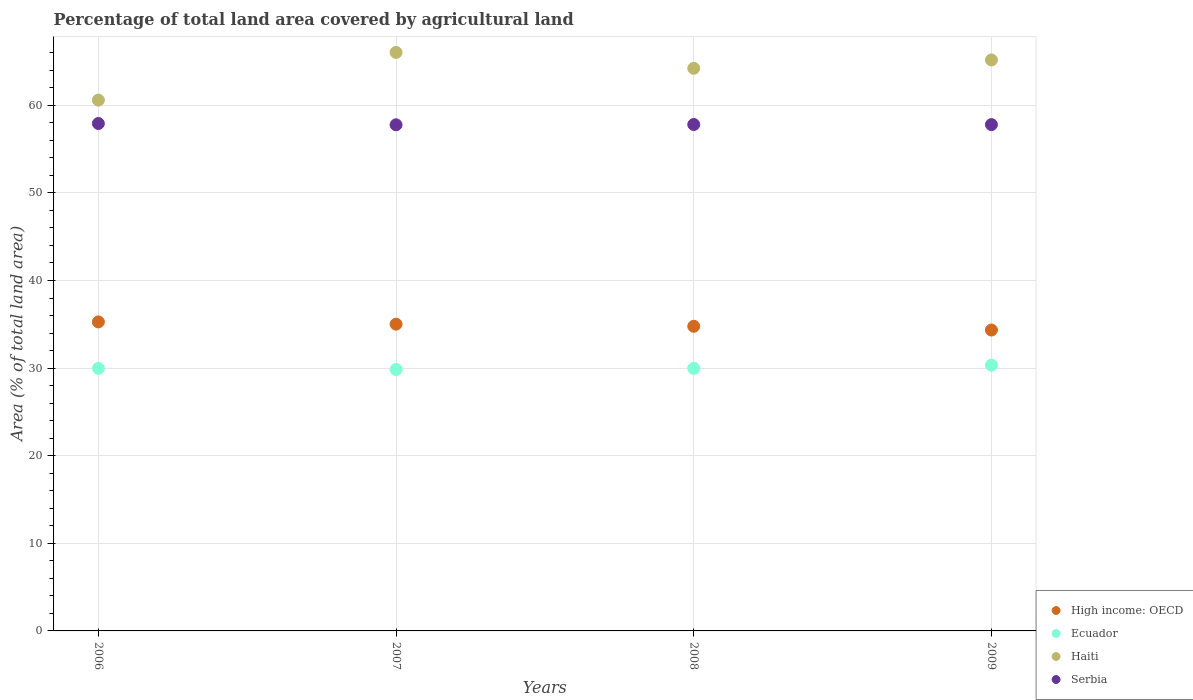How many different coloured dotlines are there?
Keep it short and to the point. 4. Is the number of dotlines equal to the number of legend labels?
Offer a very short reply. Yes. What is the percentage of agricultural land in Serbia in 2009?
Your answer should be compact. 57.8. Across all years, what is the maximum percentage of agricultural land in High income: OECD?
Give a very brief answer. 35.28. Across all years, what is the minimum percentage of agricultural land in Haiti?
Keep it short and to the point. 60.6. In which year was the percentage of agricultural land in Ecuador minimum?
Give a very brief answer. 2007. What is the total percentage of agricultural land in Ecuador in the graph?
Offer a very short reply. 120.13. What is the difference between the percentage of agricultural land in Ecuador in 2006 and that in 2008?
Offer a terse response. -0. What is the difference between the percentage of agricultural land in Serbia in 2007 and the percentage of agricultural land in Ecuador in 2008?
Offer a very short reply. 27.8. What is the average percentage of agricultural land in Ecuador per year?
Ensure brevity in your answer.  30.03. In the year 2006, what is the difference between the percentage of agricultural land in Serbia and percentage of agricultural land in Ecuador?
Give a very brief answer. 27.95. In how many years, is the percentage of agricultural land in High income: OECD greater than 16 %?
Make the answer very short. 4. What is the ratio of the percentage of agricultural land in Ecuador in 2007 to that in 2008?
Offer a terse response. 1. What is the difference between the highest and the second highest percentage of agricultural land in Ecuador?
Give a very brief answer. 0.36. What is the difference between the highest and the lowest percentage of agricultural land in Serbia?
Your answer should be compact. 0.15. In how many years, is the percentage of agricultural land in Ecuador greater than the average percentage of agricultural land in Ecuador taken over all years?
Give a very brief answer. 1. Is the sum of the percentage of agricultural land in Ecuador in 2006 and 2007 greater than the maximum percentage of agricultural land in High income: OECD across all years?
Provide a succinct answer. Yes. Is it the case that in every year, the sum of the percentage of agricultural land in High income: OECD and percentage of agricultural land in Serbia  is greater than the sum of percentage of agricultural land in Ecuador and percentage of agricultural land in Haiti?
Offer a terse response. Yes. Is the percentage of agricultural land in Ecuador strictly less than the percentage of agricultural land in Haiti over the years?
Make the answer very short. Yes. How many dotlines are there?
Offer a terse response. 4. Does the graph contain grids?
Provide a short and direct response. Yes. How are the legend labels stacked?
Offer a terse response. Vertical. What is the title of the graph?
Provide a succinct answer. Percentage of total land area covered by agricultural land. Does "Palau" appear as one of the legend labels in the graph?
Offer a very short reply. No. What is the label or title of the Y-axis?
Make the answer very short. Area (% of total land area). What is the Area (% of total land area) in High income: OECD in 2006?
Offer a terse response. 35.28. What is the Area (% of total land area) in Ecuador in 2006?
Provide a short and direct response. 29.97. What is the Area (% of total land area) of Haiti in 2006?
Offer a very short reply. 60.6. What is the Area (% of total land area) in Serbia in 2006?
Offer a very short reply. 57.92. What is the Area (% of total land area) of High income: OECD in 2007?
Your answer should be compact. 35.02. What is the Area (% of total land area) of Ecuador in 2007?
Offer a very short reply. 29.84. What is the Area (% of total land area) of Haiti in 2007?
Keep it short and to the point. 66.04. What is the Area (% of total land area) in Serbia in 2007?
Keep it short and to the point. 57.77. What is the Area (% of total land area) of High income: OECD in 2008?
Your response must be concise. 34.77. What is the Area (% of total land area) in Ecuador in 2008?
Provide a short and direct response. 29.98. What is the Area (% of total land area) in Haiti in 2008?
Give a very brief answer. 64.22. What is the Area (% of total land area) in Serbia in 2008?
Your answer should be compact. 57.81. What is the Area (% of total land area) in High income: OECD in 2009?
Provide a short and direct response. 34.35. What is the Area (% of total land area) of Ecuador in 2009?
Provide a succinct answer. 30.34. What is the Area (% of total land area) of Haiti in 2009?
Keep it short and to the point. 65.18. What is the Area (% of total land area) of Serbia in 2009?
Ensure brevity in your answer.  57.8. Across all years, what is the maximum Area (% of total land area) in High income: OECD?
Keep it short and to the point. 35.28. Across all years, what is the maximum Area (% of total land area) in Ecuador?
Your answer should be compact. 30.34. Across all years, what is the maximum Area (% of total land area) in Haiti?
Provide a succinct answer. 66.04. Across all years, what is the maximum Area (% of total land area) in Serbia?
Your response must be concise. 57.92. Across all years, what is the minimum Area (% of total land area) in High income: OECD?
Give a very brief answer. 34.35. Across all years, what is the minimum Area (% of total land area) of Ecuador?
Provide a succinct answer. 29.84. Across all years, what is the minimum Area (% of total land area) of Haiti?
Offer a very short reply. 60.6. Across all years, what is the minimum Area (% of total land area) of Serbia?
Provide a short and direct response. 57.77. What is the total Area (% of total land area) in High income: OECD in the graph?
Keep it short and to the point. 139.42. What is the total Area (% of total land area) of Ecuador in the graph?
Your response must be concise. 120.13. What is the total Area (% of total land area) in Haiti in the graph?
Your response must be concise. 256.04. What is the total Area (% of total land area) in Serbia in the graph?
Ensure brevity in your answer.  231.31. What is the difference between the Area (% of total land area) in High income: OECD in 2006 and that in 2007?
Your answer should be compact. 0.26. What is the difference between the Area (% of total land area) of Ecuador in 2006 and that in 2007?
Give a very brief answer. 0.13. What is the difference between the Area (% of total land area) of Haiti in 2006 and that in 2007?
Your answer should be compact. -5.44. What is the difference between the Area (% of total land area) of Serbia in 2006 and that in 2007?
Your response must be concise. 0.15. What is the difference between the Area (% of total land area) of High income: OECD in 2006 and that in 2008?
Ensure brevity in your answer.  0.5. What is the difference between the Area (% of total land area) in Ecuador in 2006 and that in 2008?
Give a very brief answer. -0. What is the difference between the Area (% of total land area) in Haiti in 2006 and that in 2008?
Provide a short and direct response. -3.63. What is the difference between the Area (% of total land area) of Serbia in 2006 and that in 2008?
Keep it short and to the point. 0.11. What is the difference between the Area (% of total land area) of High income: OECD in 2006 and that in 2009?
Provide a succinct answer. 0.93. What is the difference between the Area (% of total land area) of Ecuador in 2006 and that in 2009?
Offer a very short reply. -0.36. What is the difference between the Area (% of total land area) of Haiti in 2006 and that in 2009?
Your response must be concise. -4.58. What is the difference between the Area (% of total land area) of Serbia in 2006 and that in 2009?
Provide a succinct answer. 0.13. What is the difference between the Area (% of total land area) of High income: OECD in 2007 and that in 2008?
Offer a very short reply. 0.24. What is the difference between the Area (% of total land area) in Ecuador in 2007 and that in 2008?
Provide a succinct answer. -0.13. What is the difference between the Area (% of total land area) in Haiti in 2007 and that in 2008?
Keep it short and to the point. 1.81. What is the difference between the Area (% of total land area) of Serbia in 2007 and that in 2008?
Provide a short and direct response. -0.03. What is the difference between the Area (% of total land area) in High income: OECD in 2007 and that in 2009?
Give a very brief answer. 0.67. What is the difference between the Area (% of total land area) of Ecuador in 2007 and that in 2009?
Provide a succinct answer. -0.49. What is the difference between the Area (% of total land area) in Haiti in 2007 and that in 2009?
Your answer should be compact. 0.86. What is the difference between the Area (% of total land area) in Serbia in 2007 and that in 2009?
Make the answer very short. -0.02. What is the difference between the Area (% of total land area) of High income: OECD in 2008 and that in 2009?
Your answer should be compact. 0.43. What is the difference between the Area (% of total land area) in Ecuador in 2008 and that in 2009?
Your answer should be compact. -0.36. What is the difference between the Area (% of total land area) in Haiti in 2008 and that in 2009?
Provide a short and direct response. -0.96. What is the difference between the Area (% of total land area) of Serbia in 2008 and that in 2009?
Make the answer very short. 0.01. What is the difference between the Area (% of total land area) of High income: OECD in 2006 and the Area (% of total land area) of Ecuador in 2007?
Your response must be concise. 5.43. What is the difference between the Area (% of total land area) in High income: OECD in 2006 and the Area (% of total land area) in Haiti in 2007?
Keep it short and to the point. -30.76. What is the difference between the Area (% of total land area) in High income: OECD in 2006 and the Area (% of total land area) in Serbia in 2007?
Offer a terse response. -22.5. What is the difference between the Area (% of total land area) of Ecuador in 2006 and the Area (% of total land area) of Haiti in 2007?
Your answer should be compact. -36.07. What is the difference between the Area (% of total land area) in Ecuador in 2006 and the Area (% of total land area) in Serbia in 2007?
Offer a terse response. -27.8. What is the difference between the Area (% of total land area) in Haiti in 2006 and the Area (% of total land area) in Serbia in 2007?
Offer a terse response. 2.82. What is the difference between the Area (% of total land area) of High income: OECD in 2006 and the Area (% of total land area) of Ecuador in 2008?
Offer a terse response. 5.3. What is the difference between the Area (% of total land area) in High income: OECD in 2006 and the Area (% of total land area) in Haiti in 2008?
Offer a terse response. -28.95. What is the difference between the Area (% of total land area) in High income: OECD in 2006 and the Area (% of total land area) in Serbia in 2008?
Your answer should be very brief. -22.53. What is the difference between the Area (% of total land area) in Ecuador in 2006 and the Area (% of total land area) in Haiti in 2008?
Offer a terse response. -34.25. What is the difference between the Area (% of total land area) of Ecuador in 2006 and the Area (% of total land area) of Serbia in 2008?
Give a very brief answer. -27.84. What is the difference between the Area (% of total land area) of Haiti in 2006 and the Area (% of total land area) of Serbia in 2008?
Provide a short and direct response. 2.79. What is the difference between the Area (% of total land area) of High income: OECD in 2006 and the Area (% of total land area) of Ecuador in 2009?
Provide a succinct answer. 4.94. What is the difference between the Area (% of total land area) of High income: OECD in 2006 and the Area (% of total land area) of Haiti in 2009?
Keep it short and to the point. -29.9. What is the difference between the Area (% of total land area) in High income: OECD in 2006 and the Area (% of total land area) in Serbia in 2009?
Offer a terse response. -22.52. What is the difference between the Area (% of total land area) of Ecuador in 2006 and the Area (% of total land area) of Haiti in 2009?
Offer a very short reply. -35.21. What is the difference between the Area (% of total land area) of Ecuador in 2006 and the Area (% of total land area) of Serbia in 2009?
Give a very brief answer. -27.83. What is the difference between the Area (% of total land area) of Haiti in 2006 and the Area (% of total land area) of Serbia in 2009?
Your answer should be very brief. 2.8. What is the difference between the Area (% of total land area) of High income: OECD in 2007 and the Area (% of total land area) of Ecuador in 2008?
Make the answer very short. 5.04. What is the difference between the Area (% of total land area) of High income: OECD in 2007 and the Area (% of total land area) of Haiti in 2008?
Your answer should be compact. -29.2. What is the difference between the Area (% of total land area) in High income: OECD in 2007 and the Area (% of total land area) in Serbia in 2008?
Your answer should be very brief. -22.79. What is the difference between the Area (% of total land area) of Ecuador in 2007 and the Area (% of total land area) of Haiti in 2008?
Provide a succinct answer. -34.38. What is the difference between the Area (% of total land area) of Ecuador in 2007 and the Area (% of total land area) of Serbia in 2008?
Your answer should be compact. -27.97. What is the difference between the Area (% of total land area) of Haiti in 2007 and the Area (% of total land area) of Serbia in 2008?
Offer a terse response. 8.23. What is the difference between the Area (% of total land area) of High income: OECD in 2007 and the Area (% of total land area) of Ecuador in 2009?
Your answer should be compact. 4.68. What is the difference between the Area (% of total land area) of High income: OECD in 2007 and the Area (% of total land area) of Haiti in 2009?
Make the answer very short. -30.16. What is the difference between the Area (% of total land area) of High income: OECD in 2007 and the Area (% of total land area) of Serbia in 2009?
Ensure brevity in your answer.  -22.78. What is the difference between the Area (% of total land area) in Ecuador in 2007 and the Area (% of total land area) in Haiti in 2009?
Your response must be concise. -35.34. What is the difference between the Area (% of total land area) in Ecuador in 2007 and the Area (% of total land area) in Serbia in 2009?
Provide a succinct answer. -27.95. What is the difference between the Area (% of total land area) of Haiti in 2007 and the Area (% of total land area) of Serbia in 2009?
Your response must be concise. 8.24. What is the difference between the Area (% of total land area) in High income: OECD in 2008 and the Area (% of total land area) in Ecuador in 2009?
Make the answer very short. 4.44. What is the difference between the Area (% of total land area) in High income: OECD in 2008 and the Area (% of total land area) in Haiti in 2009?
Offer a very short reply. -30.4. What is the difference between the Area (% of total land area) of High income: OECD in 2008 and the Area (% of total land area) of Serbia in 2009?
Your response must be concise. -23.02. What is the difference between the Area (% of total land area) in Ecuador in 2008 and the Area (% of total land area) in Haiti in 2009?
Give a very brief answer. -35.2. What is the difference between the Area (% of total land area) of Ecuador in 2008 and the Area (% of total land area) of Serbia in 2009?
Your answer should be very brief. -27.82. What is the difference between the Area (% of total land area) in Haiti in 2008 and the Area (% of total land area) in Serbia in 2009?
Your answer should be very brief. 6.43. What is the average Area (% of total land area) of High income: OECD per year?
Provide a succinct answer. 34.85. What is the average Area (% of total land area) of Ecuador per year?
Provide a succinct answer. 30.03. What is the average Area (% of total land area) in Haiti per year?
Your answer should be very brief. 64.01. What is the average Area (% of total land area) of Serbia per year?
Ensure brevity in your answer.  57.83. In the year 2006, what is the difference between the Area (% of total land area) of High income: OECD and Area (% of total land area) of Ecuador?
Ensure brevity in your answer.  5.3. In the year 2006, what is the difference between the Area (% of total land area) of High income: OECD and Area (% of total land area) of Haiti?
Your answer should be very brief. -25.32. In the year 2006, what is the difference between the Area (% of total land area) in High income: OECD and Area (% of total land area) in Serbia?
Your response must be concise. -22.65. In the year 2006, what is the difference between the Area (% of total land area) in Ecuador and Area (% of total land area) in Haiti?
Your answer should be very brief. -30.62. In the year 2006, what is the difference between the Area (% of total land area) of Ecuador and Area (% of total land area) of Serbia?
Keep it short and to the point. -27.95. In the year 2006, what is the difference between the Area (% of total land area) in Haiti and Area (% of total land area) in Serbia?
Offer a very short reply. 2.67. In the year 2007, what is the difference between the Area (% of total land area) in High income: OECD and Area (% of total land area) in Ecuador?
Keep it short and to the point. 5.17. In the year 2007, what is the difference between the Area (% of total land area) of High income: OECD and Area (% of total land area) of Haiti?
Make the answer very short. -31.02. In the year 2007, what is the difference between the Area (% of total land area) of High income: OECD and Area (% of total land area) of Serbia?
Provide a succinct answer. -22.76. In the year 2007, what is the difference between the Area (% of total land area) of Ecuador and Area (% of total land area) of Haiti?
Offer a very short reply. -36.19. In the year 2007, what is the difference between the Area (% of total land area) of Ecuador and Area (% of total land area) of Serbia?
Your response must be concise. -27.93. In the year 2007, what is the difference between the Area (% of total land area) of Haiti and Area (% of total land area) of Serbia?
Give a very brief answer. 8.26. In the year 2008, what is the difference between the Area (% of total land area) in High income: OECD and Area (% of total land area) in Ecuador?
Your answer should be very brief. 4.8. In the year 2008, what is the difference between the Area (% of total land area) in High income: OECD and Area (% of total land area) in Haiti?
Make the answer very short. -29.45. In the year 2008, what is the difference between the Area (% of total land area) in High income: OECD and Area (% of total land area) in Serbia?
Make the answer very short. -23.03. In the year 2008, what is the difference between the Area (% of total land area) of Ecuador and Area (% of total land area) of Haiti?
Your response must be concise. -34.25. In the year 2008, what is the difference between the Area (% of total land area) in Ecuador and Area (% of total land area) in Serbia?
Ensure brevity in your answer.  -27.83. In the year 2008, what is the difference between the Area (% of total land area) in Haiti and Area (% of total land area) in Serbia?
Keep it short and to the point. 6.41. In the year 2009, what is the difference between the Area (% of total land area) of High income: OECD and Area (% of total land area) of Ecuador?
Make the answer very short. 4.01. In the year 2009, what is the difference between the Area (% of total land area) in High income: OECD and Area (% of total land area) in Haiti?
Provide a short and direct response. -30.83. In the year 2009, what is the difference between the Area (% of total land area) of High income: OECD and Area (% of total land area) of Serbia?
Offer a very short reply. -23.45. In the year 2009, what is the difference between the Area (% of total land area) of Ecuador and Area (% of total land area) of Haiti?
Offer a terse response. -34.84. In the year 2009, what is the difference between the Area (% of total land area) in Ecuador and Area (% of total land area) in Serbia?
Your answer should be very brief. -27.46. In the year 2009, what is the difference between the Area (% of total land area) of Haiti and Area (% of total land area) of Serbia?
Offer a very short reply. 7.38. What is the ratio of the Area (% of total land area) of High income: OECD in 2006 to that in 2007?
Provide a succinct answer. 1.01. What is the ratio of the Area (% of total land area) in Haiti in 2006 to that in 2007?
Provide a short and direct response. 0.92. What is the ratio of the Area (% of total land area) of Serbia in 2006 to that in 2007?
Your answer should be compact. 1. What is the ratio of the Area (% of total land area) in High income: OECD in 2006 to that in 2008?
Provide a succinct answer. 1.01. What is the ratio of the Area (% of total land area) in Ecuador in 2006 to that in 2008?
Give a very brief answer. 1. What is the ratio of the Area (% of total land area) in Haiti in 2006 to that in 2008?
Ensure brevity in your answer.  0.94. What is the ratio of the Area (% of total land area) of Serbia in 2006 to that in 2008?
Keep it short and to the point. 1. What is the ratio of the Area (% of total land area) of High income: OECD in 2006 to that in 2009?
Your answer should be very brief. 1.03. What is the ratio of the Area (% of total land area) of Haiti in 2006 to that in 2009?
Make the answer very short. 0.93. What is the ratio of the Area (% of total land area) of High income: OECD in 2007 to that in 2008?
Your response must be concise. 1.01. What is the ratio of the Area (% of total land area) in Ecuador in 2007 to that in 2008?
Keep it short and to the point. 1. What is the ratio of the Area (% of total land area) in Haiti in 2007 to that in 2008?
Ensure brevity in your answer.  1.03. What is the ratio of the Area (% of total land area) in High income: OECD in 2007 to that in 2009?
Give a very brief answer. 1.02. What is the ratio of the Area (% of total land area) of Ecuador in 2007 to that in 2009?
Make the answer very short. 0.98. What is the ratio of the Area (% of total land area) of Haiti in 2007 to that in 2009?
Provide a short and direct response. 1.01. What is the ratio of the Area (% of total land area) in High income: OECD in 2008 to that in 2009?
Provide a succinct answer. 1.01. What is the ratio of the Area (% of total land area) in Ecuador in 2008 to that in 2009?
Ensure brevity in your answer.  0.99. What is the ratio of the Area (% of total land area) in Haiti in 2008 to that in 2009?
Make the answer very short. 0.99. What is the difference between the highest and the second highest Area (% of total land area) of High income: OECD?
Provide a succinct answer. 0.26. What is the difference between the highest and the second highest Area (% of total land area) of Ecuador?
Give a very brief answer. 0.36. What is the difference between the highest and the second highest Area (% of total land area) in Haiti?
Your answer should be very brief. 0.86. What is the difference between the highest and the second highest Area (% of total land area) in Serbia?
Your answer should be very brief. 0.11. What is the difference between the highest and the lowest Area (% of total land area) in High income: OECD?
Give a very brief answer. 0.93. What is the difference between the highest and the lowest Area (% of total land area) of Ecuador?
Provide a succinct answer. 0.49. What is the difference between the highest and the lowest Area (% of total land area) in Haiti?
Keep it short and to the point. 5.44. What is the difference between the highest and the lowest Area (% of total land area) of Serbia?
Give a very brief answer. 0.15. 